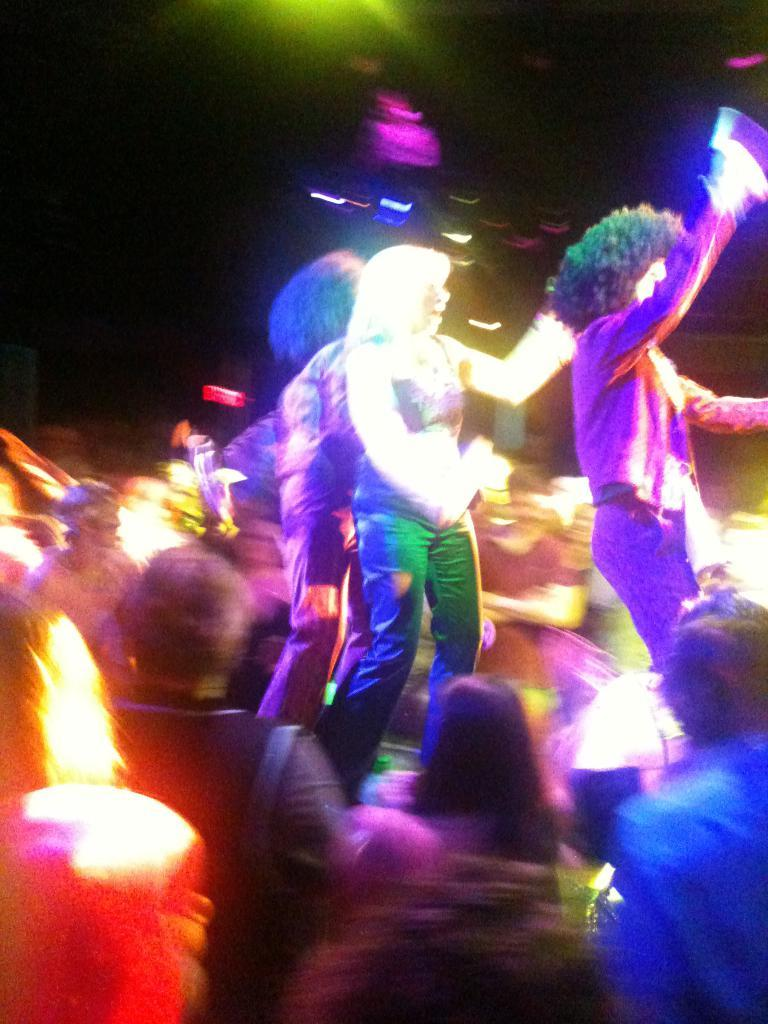How many people are in the image? There are multiple persons in the image. What is visible at the top of the image? The sky is visible at the top of the image. What type of illumination can be seen in the image? There are lights present in the image. What type of noise can be heard coming from the skate in the image? There is no skate present in the image, so it is not possible to determine what, if any, noise might be heard. 